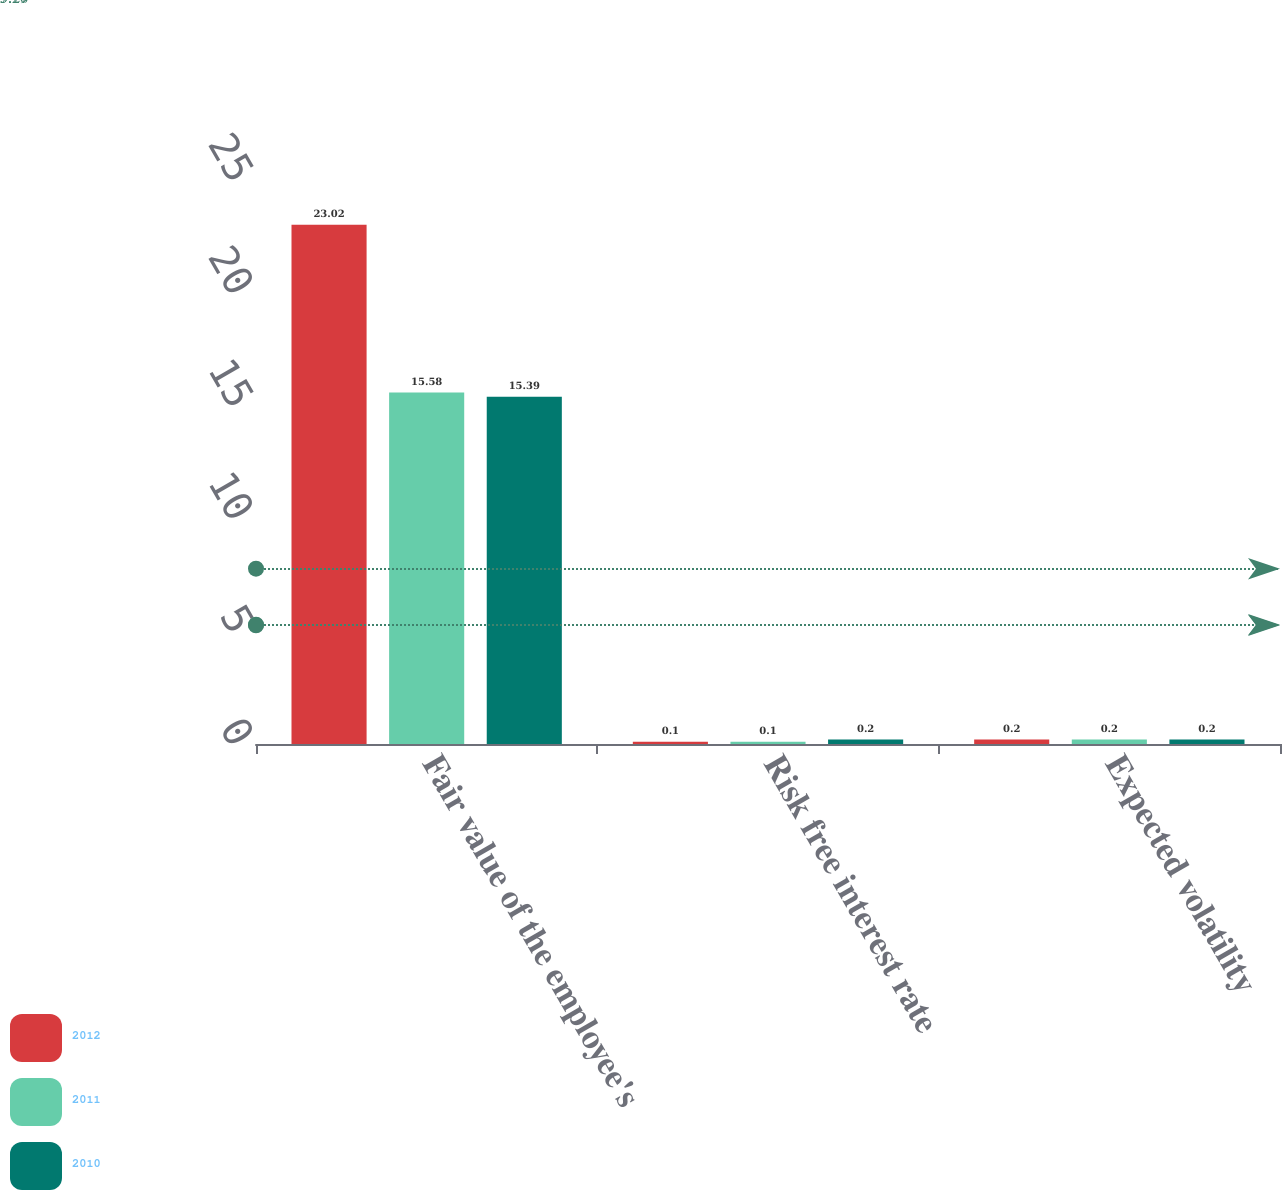Convert chart. <chart><loc_0><loc_0><loc_500><loc_500><stacked_bar_chart><ecel><fcel>Fair value of the employee's<fcel>Risk free interest rate<fcel>Expected volatility<nl><fcel>2012<fcel>23.02<fcel>0.1<fcel>0.2<nl><fcel>2011<fcel>15.58<fcel>0.1<fcel>0.2<nl><fcel>2010<fcel>15.39<fcel>0.2<fcel>0.2<nl></chart> 